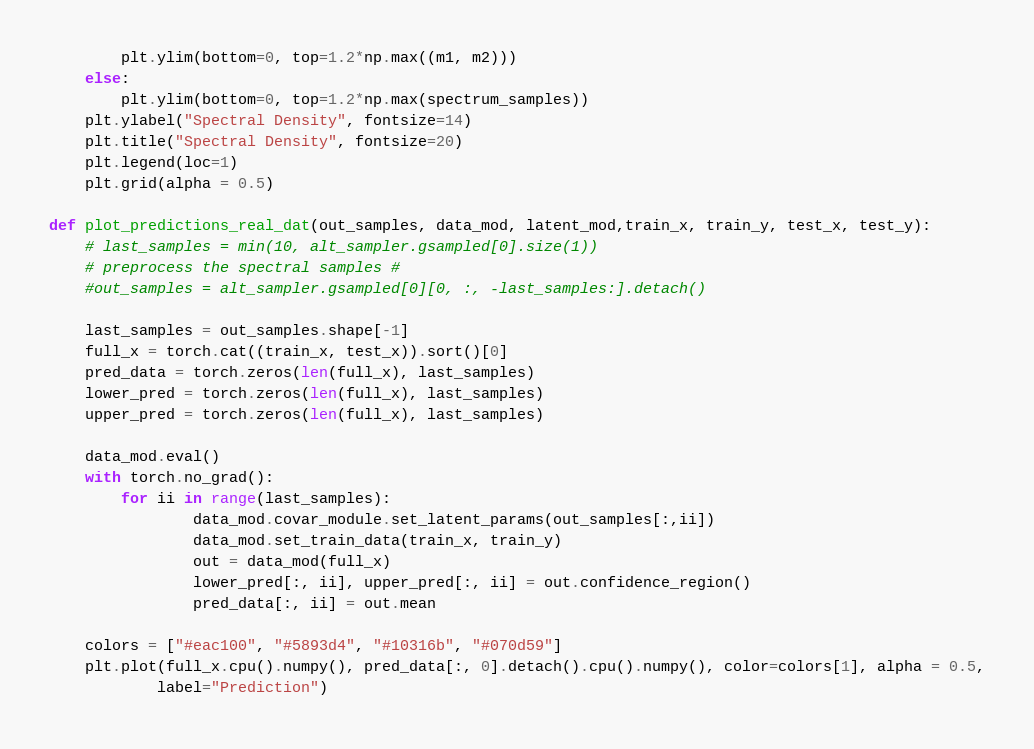<code> <loc_0><loc_0><loc_500><loc_500><_Python_>		plt.ylim(bottom=0, top=1.2*np.max((m1, m2)))
	else:
		plt.ylim(bottom=0, top=1.2*np.max(spectrum_samples))
	plt.ylabel("Spectral Density", fontsize=14)
	plt.title("Spectral Density", fontsize=20)
	plt.legend(loc=1)
	plt.grid(alpha = 0.5)

def plot_predictions_real_dat(out_samples, data_mod, latent_mod,train_x, train_y, test_x, test_y):
	# last_samples = min(10, alt_sampler.gsampled[0].size(1))
	# preprocess the spectral samples #
	#out_samples = alt_sampler.gsampled[0][0, :, -last_samples:].detach()

	last_samples = out_samples.shape[-1]
	full_x = torch.cat((train_x, test_x)).sort()[0]
	pred_data = torch.zeros(len(full_x), last_samples)
	lower_pred = torch.zeros(len(full_x), last_samples)
	upper_pred = torch.zeros(len(full_x), last_samples)

	data_mod.eval()
	with torch.no_grad():
		for ii in range(last_samples):
				data_mod.covar_module.set_latent_params(out_samples[:,ii])
				data_mod.set_train_data(train_x, train_y)
				out = data_mod(full_x)
				lower_pred[:, ii], upper_pred[:, ii] = out.confidence_region()
				pred_data[:, ii] = out.mean

	colors = ["#eac100", "#5893d4", "#10316b", "#070d59"]
	plt.plot(full_x.cpu().numpy(), pred_data[:, 0].detach().cpu().numpy(), color=colors[1], alpha = 0.5,
			label="Prediction")</code> 